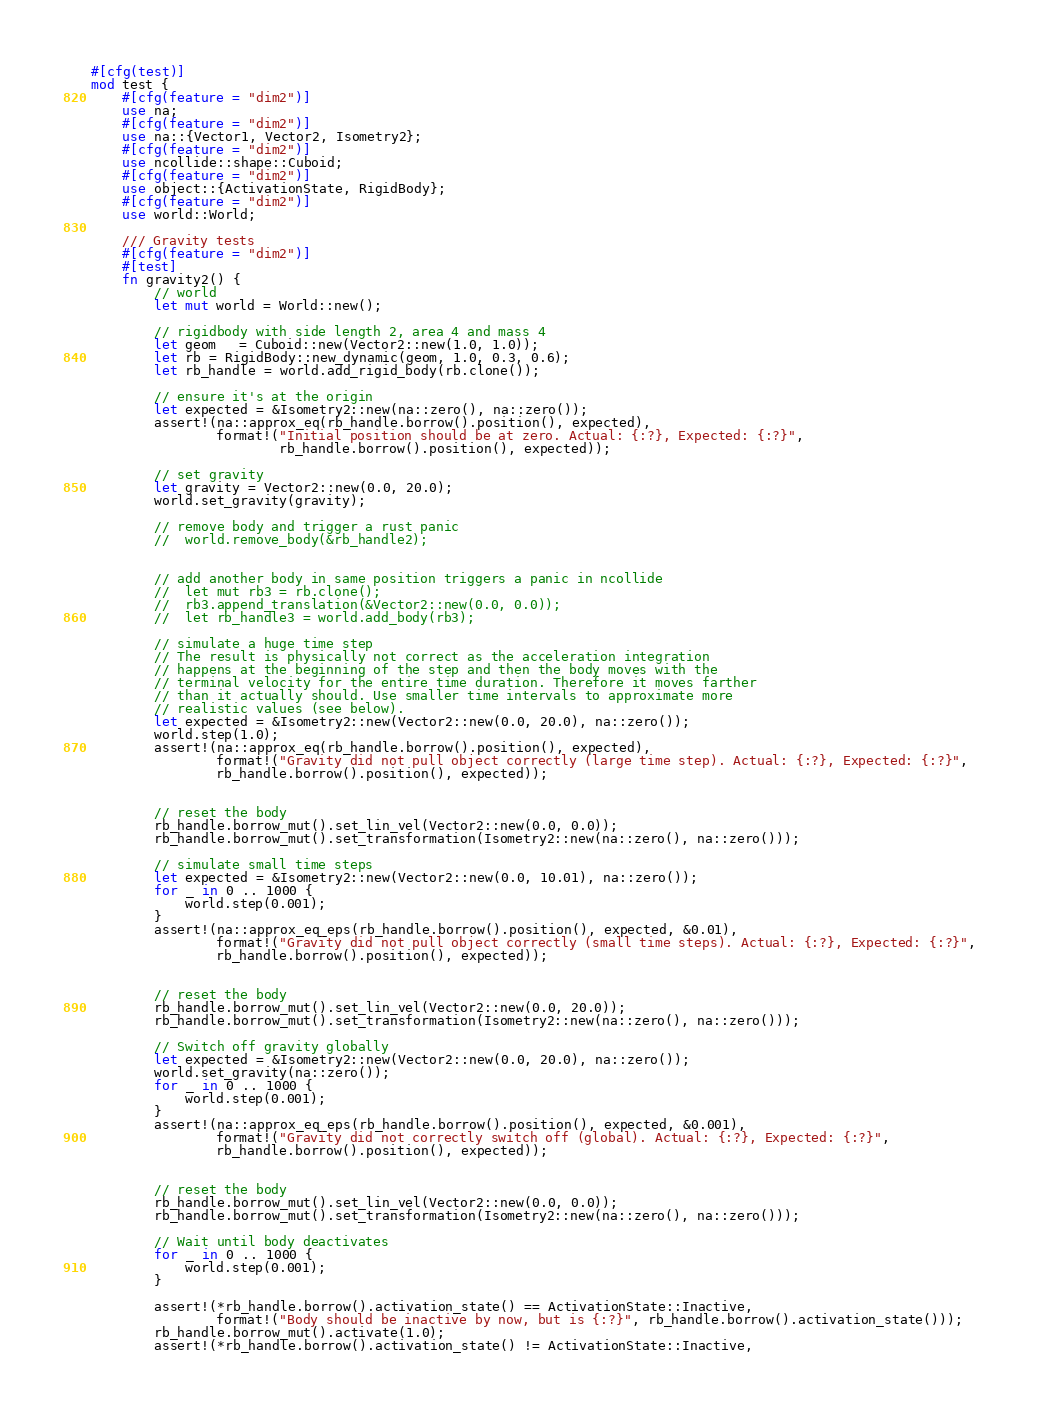Convert code to text. <code><loc_0><loc_0><loc_500><loc_500><_Rust_>#[cfg(test)]
mod test {
    #[cfg(feature = "dim2")]
    use na;
    #[cfg(feature = "dim2")]
    use na::{Vector1, Vector2, Isometry2};
    #[cfg(feature = "dim2")]
    use ncollide::shape::Cuboid;
    #[cfg(feature = "dim2")]
    use object::{ActivationState, RigidBody};
    #[cfg(feature = "dim2")]
    use world::World;

    /// Gravity tests
    #[cfg(feature = "dim2")]
    #[test]
    fn gravity2() {
        // world
        let mut world = World::new();

        // rigidbody with side length 2, area 4 and mass 4
        let geom   = Cuboid::new(Vector2::new(1.0, 1.0));
        let rb = RigidBody::new_dynamic(geom, 1.0, 0.3, 0.6);
        let rb_handle = world.add_rigid_body(rb.clone());

        // ensure it's at the origin
        let expected = &Isometry2::new(na::zero(), na::zero());
        assert!(na::approx_eq(rb_handle.borrow().position(), expected),
                format!("Initial position should be at zero. Actual: {:?}, Expected: {:?}",
                        rb_handle.borrow().position(), expected));

        // set gravity
        let gravity = Vector2::new(0.0, 20.0);
        world.set_gravity(gravity);

        // remove body and trigger a rust panic
        //	world.remove_body(&rb_handle2);


        // add another body in same position triggers a panic in ncollide
        // 	let mut rb3 = rb.clone();
        // 	rb3.append_translation(&Vector2::new(0.0, 0.0));
        // 	let rb_handle3 = world.add_body(rb3);

        // simulate a huge time step
        // The result is physically not correct as the acceleration integration
        // happens at the beginning of the step and then the body moves with the
        // terminal velocity for the entire time duration. Therefore it moves farther
        // than it actually should. Use smaller time intervals to approximate more
        // realistic values (see below).
        let expected = &Isometry2::new(Vector2::new(0.0, 20.0), na::zero());
        world.step(1.0);
        assert!(na::approx_eq(rb_handle.borrow().position(), expected),
                format!("Gravity did not pull object correctly (large time step). Actual: {:?}, Expected: {:?}",
                rb_handle.borrow().position(), expected));


        // reset the body
        rb_handle.borrow_mut().set_lin_vel(Vector2::new(0.0, 0.0));
        rb_handle.borrow_mut().set_transformation(Isometry2::new(na::zero(), na::zero()));

        // simulate small time steps
        let expected = &Isometry2::new(Vector2::new(0.0, 10.01), na::zero());
        for _ in 0 .. 1000 {
            world.step(0.001);
        }
        assert!(na::approx_eq_eps(rb_handle.borrow().position(), expected, &0.01),
                format!("Gravity did not pull object correctly (small time steps). Actual: {:?}, Expected: {:?}",
                rb_handle.borrow().position(), expected));


        // reset the body
        rb_handle.borrow_mut().set_lin_vel(Vector2::new(0.0, 20.0));
        rb_handle.borrow_mut().set_transformation(Isometry2::new(na::zero(), na::zero()));

        // Switch off gravity globally
        let expected = &Isometry2::new(Vector2::new(0.0, 20.0), na::zero());
        world.set_gravity(na::zero());
        for _ in 0 .. 1000 {
            world.step(0.001);
        }
        assert!(na::approx_eq_eps(rb_handle.borrow().position(), expected, &0.001),
                format!("Gravity did not correctly switch off (global). Actual: {:?}, Expected: {:?}",
                rb_handle.borrow().position(), expected));


        // reset the body
        rb_handle.borrow_mut().set_lin_vel(Vector2::new(0.0, 0.0));
        rb_handle.borrow_mut().set_transformation(Isometry2::new(na::zero(), na::zero()));

        // Wait until body deactivates
        for _ in 0 .. 1000 {
            world.step(0.001);
        }

        assert!(*rb_handle.borrow().activation_state() == ActivationState::Inactive,
                format!("Body should be inactive by now, but is {:?}", rb_handle.borrow().activation_state()));
        rb_handle.borrow_mut().activate(1.0);
        assert!(*rb_handle.borrow().activation_state() != ActivationState::Inactive,</code> 